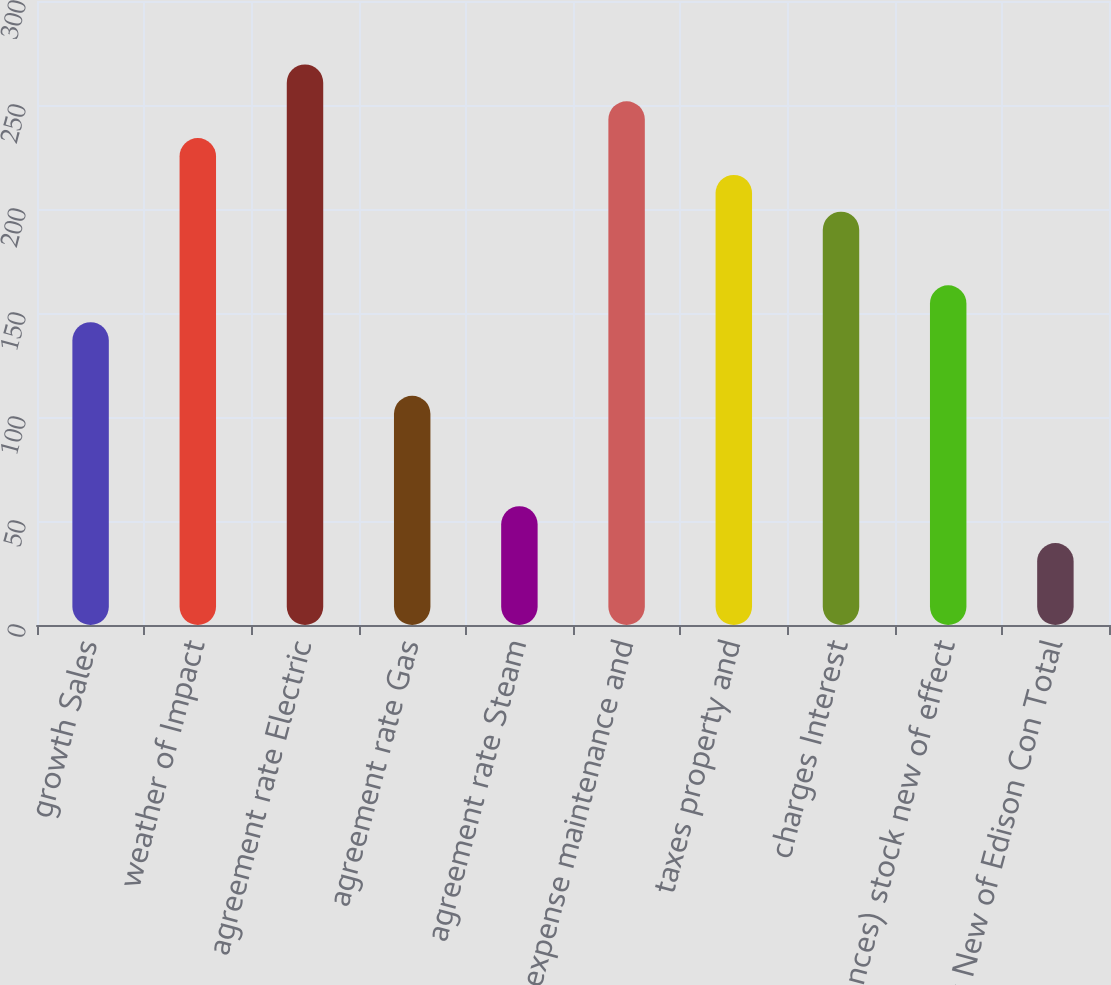<chart> <loc_0><loc_0><loc_500><loc_500><bar_chart><fcel>growth Sales<fcel>weather of Impact<fcel>agreement rate Electric<fcel>agreement rate Gas<fcel>agreement rate Steam<fcel>expense maintenance and<fcel>taxes property and<fcel>charges Interest<fcel>issuances) stock new of effect<fcel>York New of Edison Con Total<nl><fcel>145.6<fcel>234.1<fcel>269.5<fcel>110.2<fcel>57.1<fcel>251.8<fcel>216.4<fcel>198.7<fcel>163.3<fcel>39.4<nl></chart> 